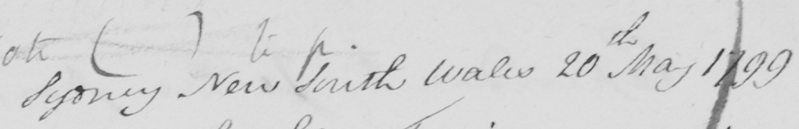Can you tell me what this handwritten text says? Sydney New South Wales 20th May 1799 